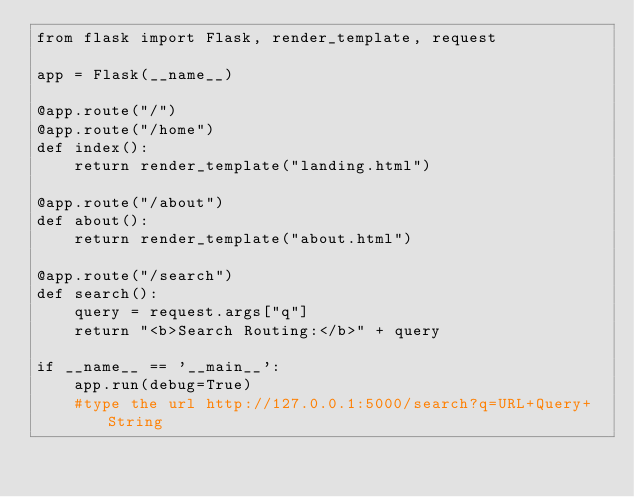<code> <loc_0><loc_0><loc_500><loc_500><_Python_>from flask import Flask, render_template, request

app = Flask(__name__)

@app.route("/")
@app.route("/home")
def index():
    return render_template("landing.html")

@app.route("/about")
def about():
    return render_template("about.html")

@app.route("/search")
def search():
    query = request.args["q"]
    return "<b>Search Routing:</b>" + query

if __name__ == '__main__':
    app.run(debug=True)
    #type the url http://127.0.0.1:5000/search?q=URL+Query+String</code> 